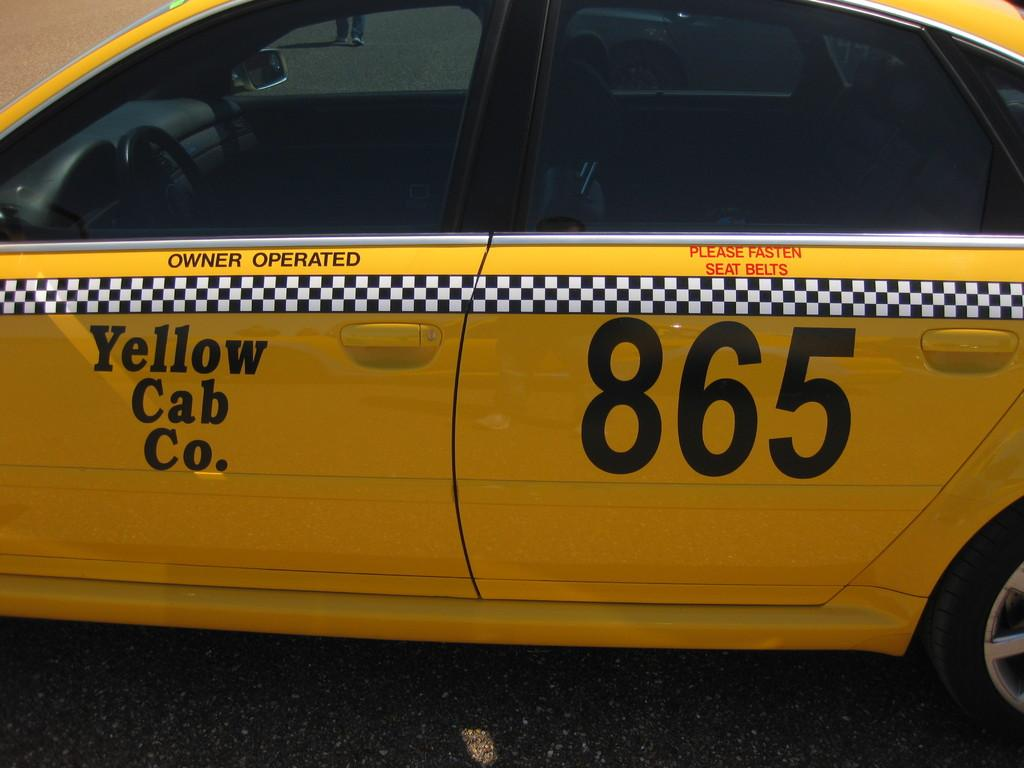<image>
Offer a succinct explanation of the picture presented. A Yellow Cab Co. 865 cab that is parked on the pavement. 